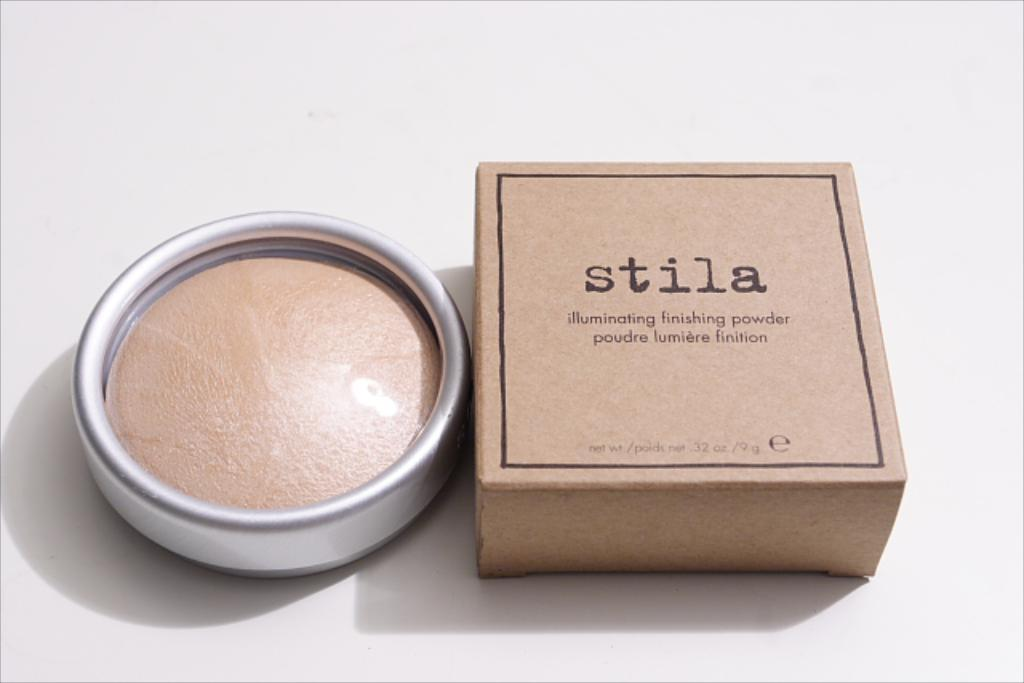<image>
Render a clear and concise summary of the photo. A box and jar of Stila illuminating finishing powder. 